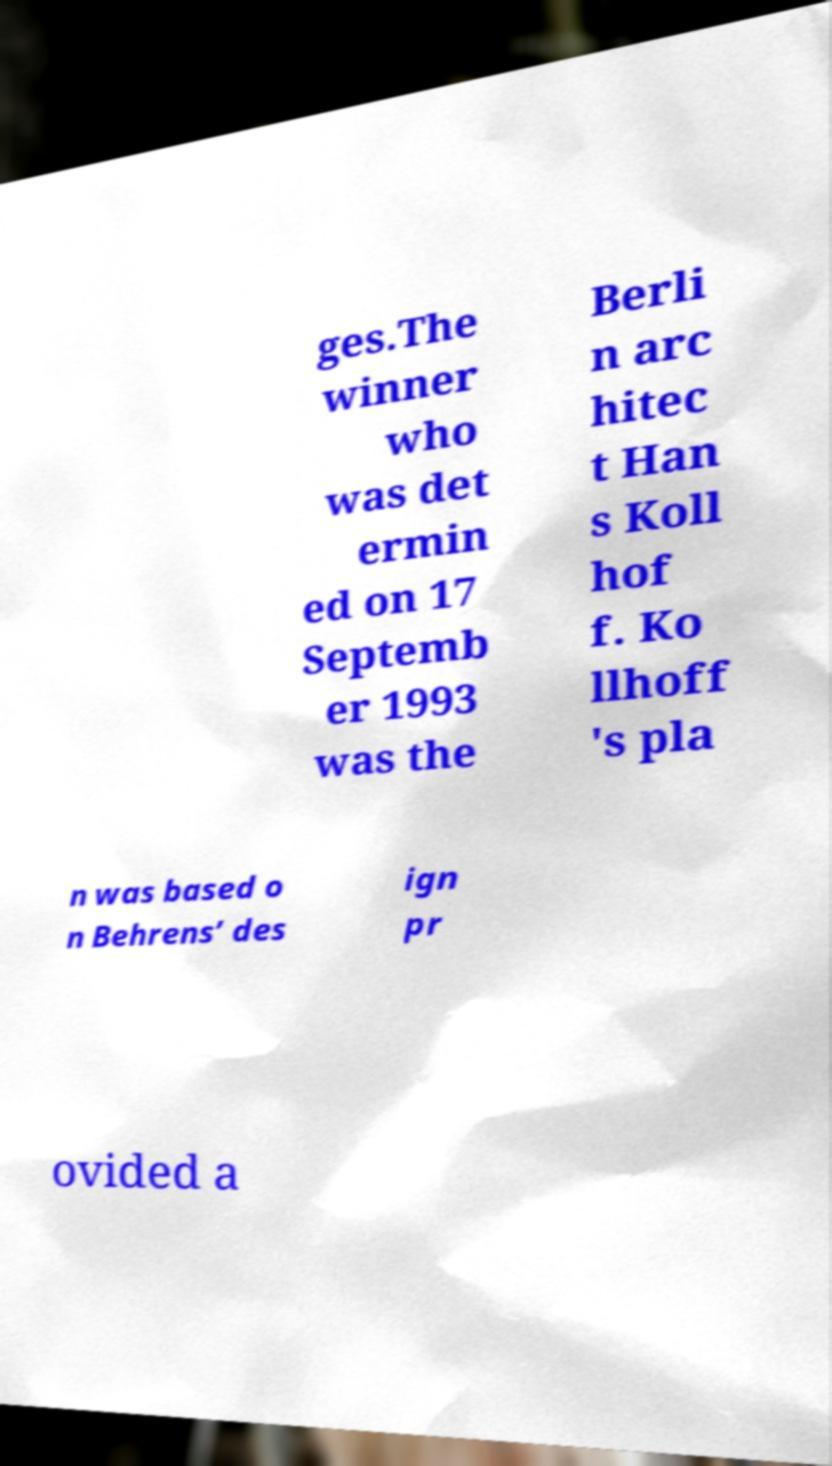Please read and relay the text visible in this image. What does it say? ges.The winner who was det ermin ed on 17 Septemb er 1993 was the Berli n arc hitec t Han s Koll hof f. Ko llhoff 's pla n was based o n Behrens’ des ign pr ovided a 